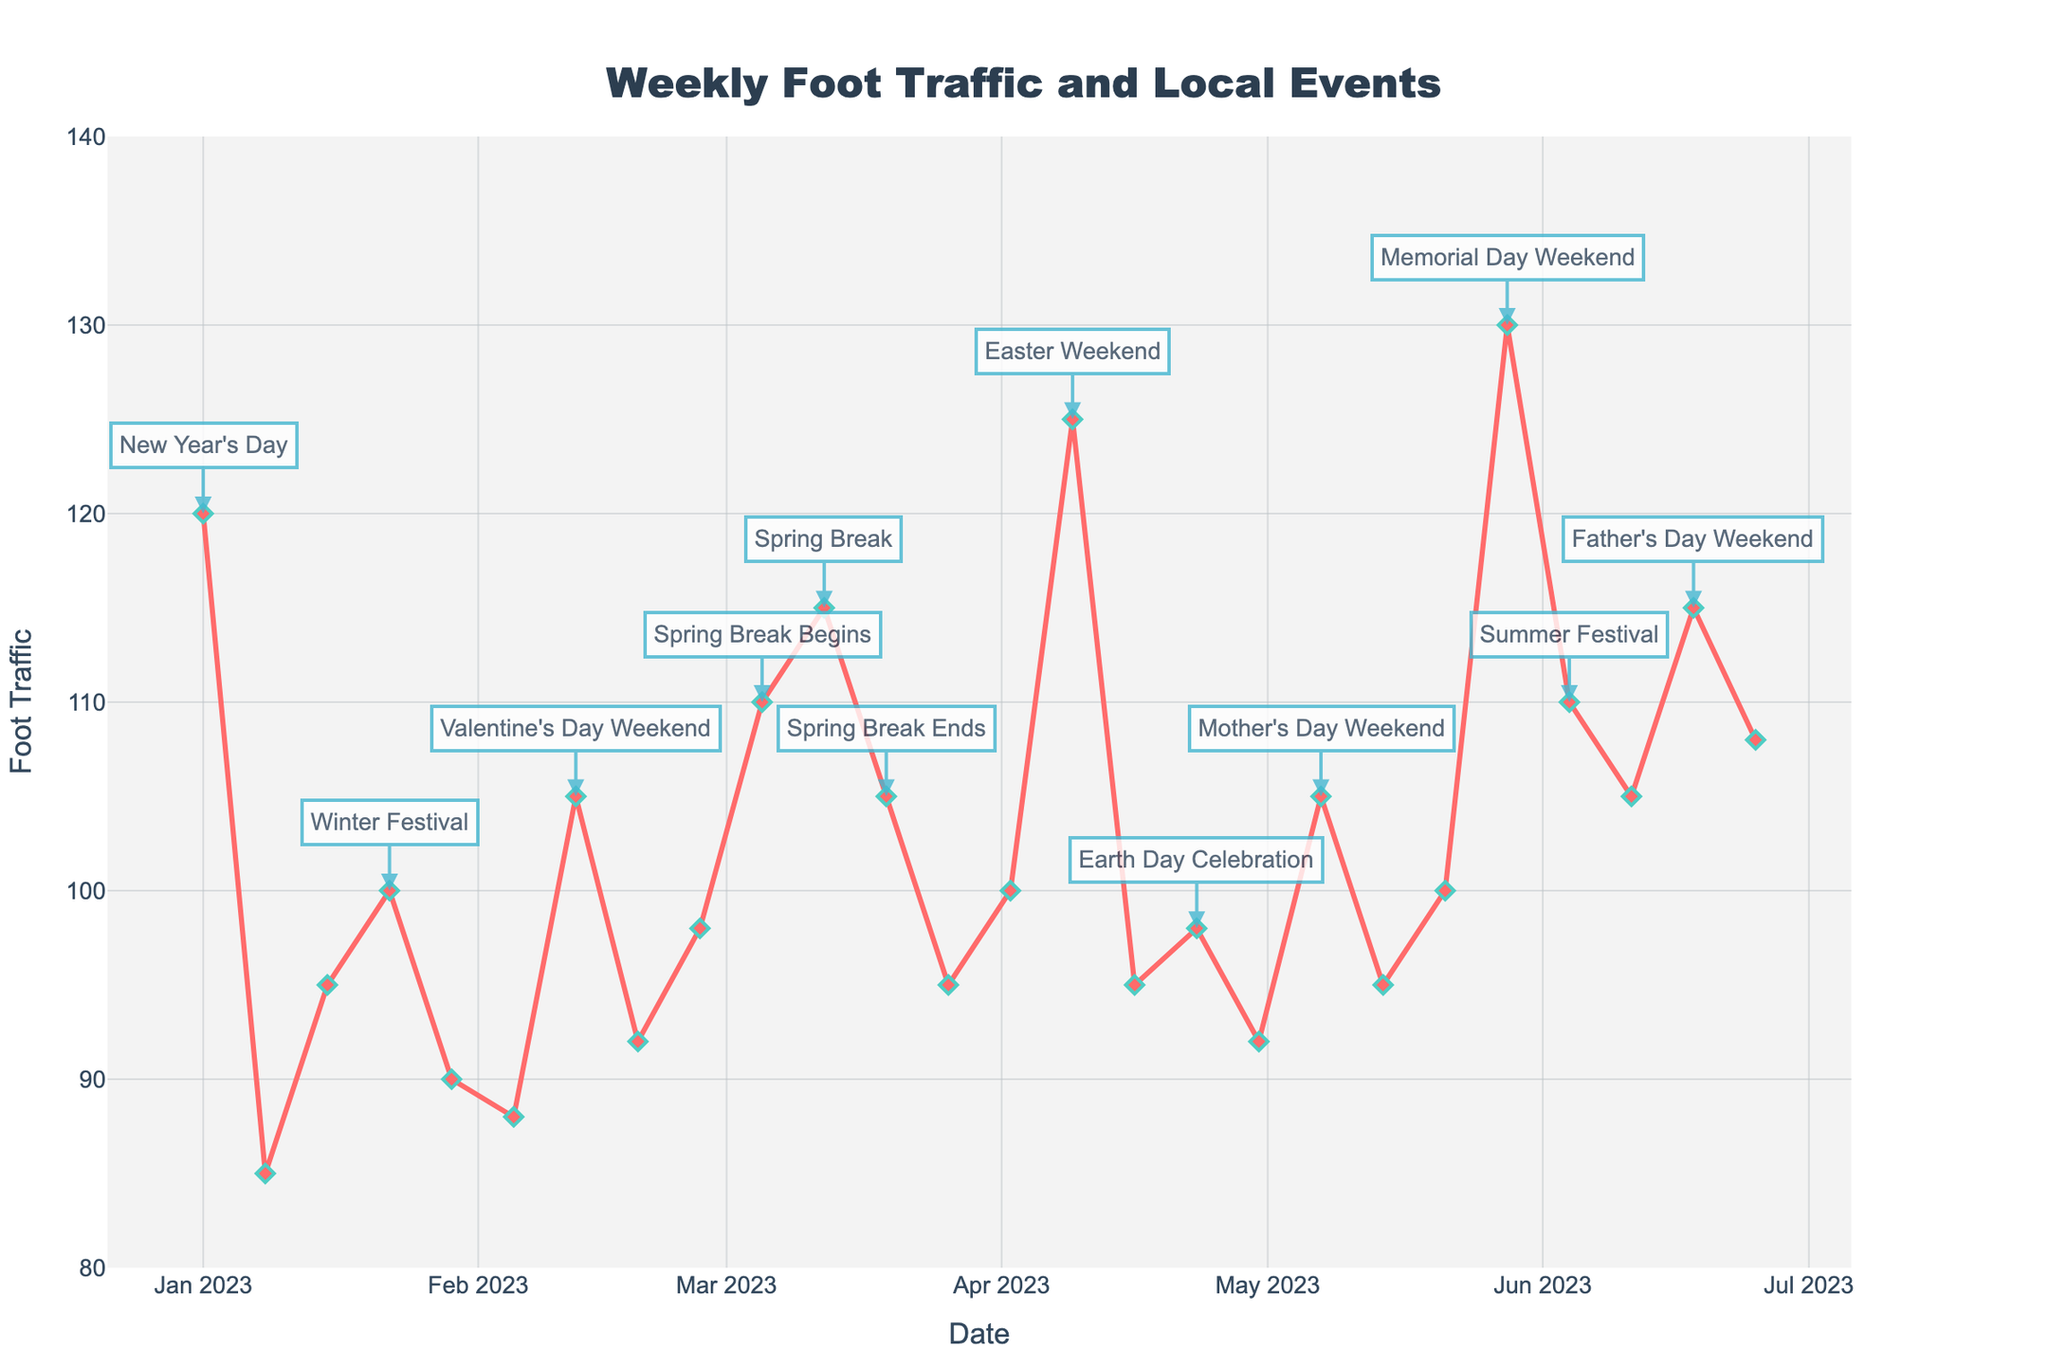What was the weekly foot traffic on Easter Weekend? Easter Weekend is labeled on April 9, and the foot traffic value for that date can be observed in the plot.
Answer: 125 Which local event corresponds to the highest foot traffic in the given period? Identify the local event corresponding to the highest peak on the plot. The highest foot traffic peak occurs on Memorial Day Weekend, May 28.
Answer: Memorial Day Weekend When comparing the foot traffic for Valentine's Day Weekend and Spring Break Begins, which had more foot traffic? Identify the foot traffic values for February 12 (Valentine's Day Weekend) and March 5 (Spring Break Begins) from the plot. Compare the values.
Answer: Spring Break Begins What is the average foot traffic during Mother's Day Weekend, Father's Day Weekend, and Easter Weekend? Sum the foot traffic values for May 7 (Mother's Day Weekend), June 18 (Father's Day Weekend), and April 9 (Easter Weekend). Then divide by 3 to get the average. (105 + 115 + 125) / 3 = 115
Answer: 115 How does the foot traffic on New Year's Day compare to that on Winter Festival? Compare the foot traffic values for January 1 (New Year's Day) and January 22 (Winter Festival) from the plot.
Answer: New Year's Day is higher Was the weekly foot traffic higher during Spring Break or on Father's Day Weekend? Compare the average foot traffic during the Spring Break period (March 5 to March 19) to the foot traffic on June 18 (Father's Day Weekend). The average for Spring Break weeks is (110 + 115 + 105) / 3 = 110. Father's Day Weekend is 115.
Answer: Father's Day Weekend What can be observed about the trend of foot traffic during the Spring Break period from March 5 to March 19? Check the weekly foot traffic values for the given dates. Identify the pattern, whether it is increasing, decreasing, or stable. The foot traffic starts at 110, peaks at 115, and then decreases to 105.
Answer: Peaks then decreases What is the difference in foot traffic between the highest and lowest recorded weeks? Identify the highest and lowest foot traffic values from the plot. The highest is 130 (Memorial Day Weekend), and the lowest is 85 (January 8). Calculate the difference: 130 - 85 = 45.
Answer: 45 How did the foot traffic on Summer Festival compare to Valentine's Day Weekend? Check the foot traffic for June 4 (Summer Festival) and February 12 (Valentine's Day Weekend). Compare the values.
Answer: Valentine's Day Weekend is higher What changes occurred in foot traffic after the Earth Day Celebration compared to the prior week? Check the foot traffic values for April 23 (Earth Day Celebration) and April 16. April 23 recorded 98, and April 16 recorded 95. Calculate the difference: 98 - 95 = 3.
Answer: Increased by 3 